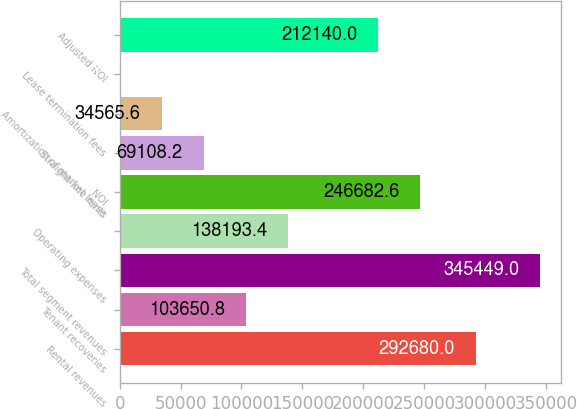Convert chart. <chart><loc_0><loc_0><loc_500><loc_500><bar_chart><fcel>Rental revenues<fcel>Tenant recoveries<fcel>Total segment revenues<fcel>Operating expenses<fcel>NOI<fcel>Straight-line rents<fcel>Amortization of market lease<fcel>Lease termination fees<fcel>Adjusted NOI<nl><fcel>292680<fcel>103651<fcel>345449<fcel>138193<fcel>246683<fcel>69108.2<fcel>34565.6<fcel>23<fcel>212140<nl></chart> 